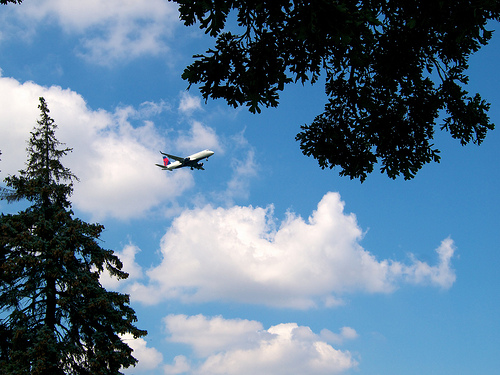What time of day does it appear to be based on the lighting and sky? Given the bright blue sky and the position of the sun reflecting off the clouds, it appears to be midday or early afternoon. 